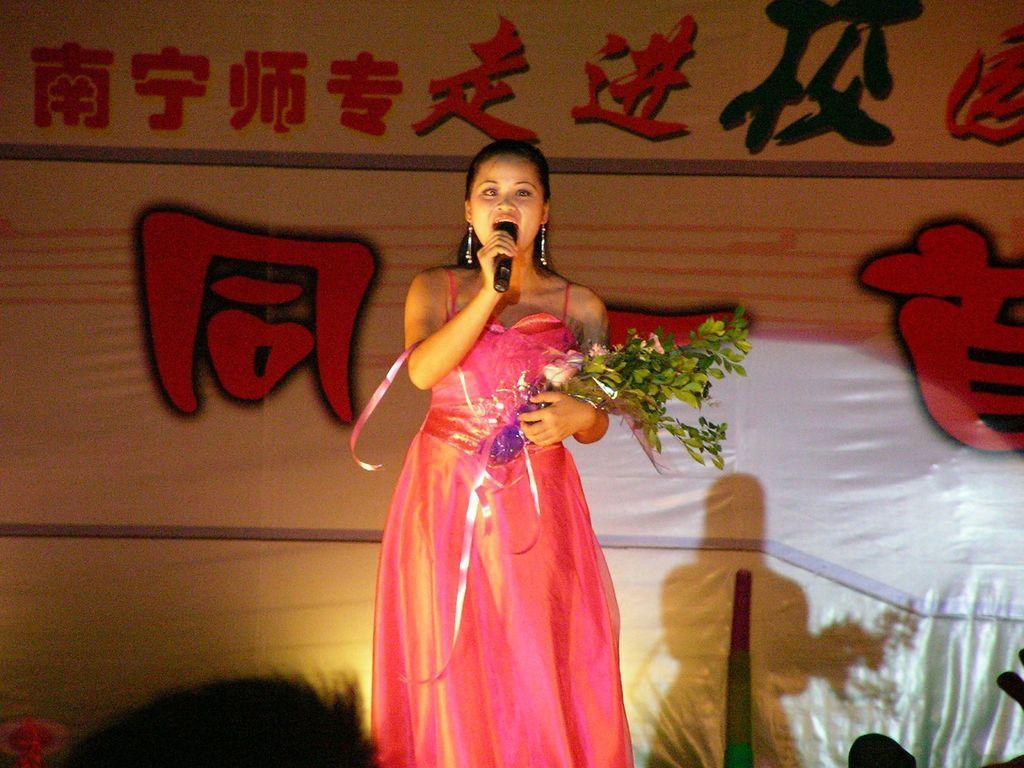Could you give a brief overview of what you see in this image? This picture is clicked in the program. Woman in pink dress is holding a flower bouquet in one of her hands and in the other hand, she is holding the microphone. She is talking on the microphone. Behind her, we see a banner in white color with some text written in different language. 